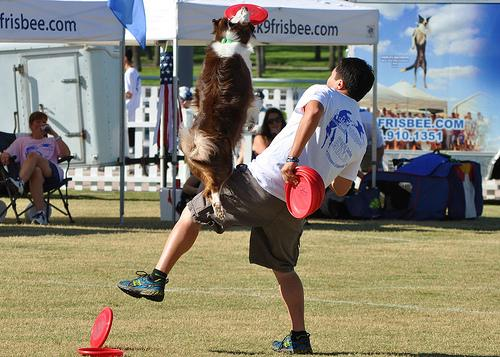Point out the details related to the dog's appearance and performance in the game. The brown and white dog is jumping to catch a frisbee and is playing frisbee with the man. Describe the outfit of the man in the image, as well as the activity he is participating in. The man, wearing a white shirt, brown shorts, and blue tennis shoes, is playing a game of frisbee with his dog. Indicate the wardrobe and appearance details of the main character in the image. The man is wearing a white shirt with a graphic print, a pair of brown shorts, blue tennis shoes with yellow lines, and he has short hair. Describe the appearance of the woman in the image. A woman wearing a pink shirt and dark sunglasses is sitting on a folding chair. Mention the most prominent colors in the image along with the objects they are associated with. There are white shirts on two men, a pink shirt on a woman, red frisbees on the ground, brown shorts on a man, and blue tennis shoes. Enumerate the actions being performed by the various subjects in the image. A man is playing frisbee with a dog, a brown and white dog is jumping to catch a frisbee, a woman is sitting in a folding chair, and someone is holding red frisbees. What are some of the unique attributes of the man and the dog in the image? The man has short hair and is wearing a graphic print shirt, while the dog is brown and white. Identify the elements in the image that depict a game of frisbee. A man playing frisbee with a dog, a jumping dog trying to catch a frisbee, several frisbees in the man's hands, and two red frisbees on the ground. Using concise language, describe the primary interaction taking place in the image. A man is engaging in a frisbee-catching game with a brown and white dog, who performs jumps to catch the frisbees. Briefly describe the scene involving the man and the dog in the image. A guy wearing a white and blue shirt with brown shorts is playing frisbee with a brown and white dog, who is jumping to catch the frisbee. 